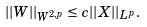Convert formula to latex. <formula><loc_0><loc_0><loc_500><loc_500>| | W | | _ { W ^ { 2 , p } } \leq c | | X | | _ { L ^ { p } } .</formula> 